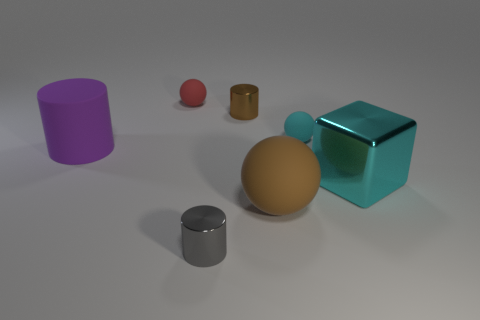Add 3 purple metal objects. How many objects exist? 10 Subtract all balls. How many objects are left? 4 Add 5 cyan rubber objects. How many cyan rubber objects are left? 6 Add 7 large matte cylinders. How many large matte cylinders exist? 8 Subtract 0 blue cylinders. How many objects are left? 7 Subtract all tiny cylinders. Subtract all tiny red matte balls. How many objects are left? 4 